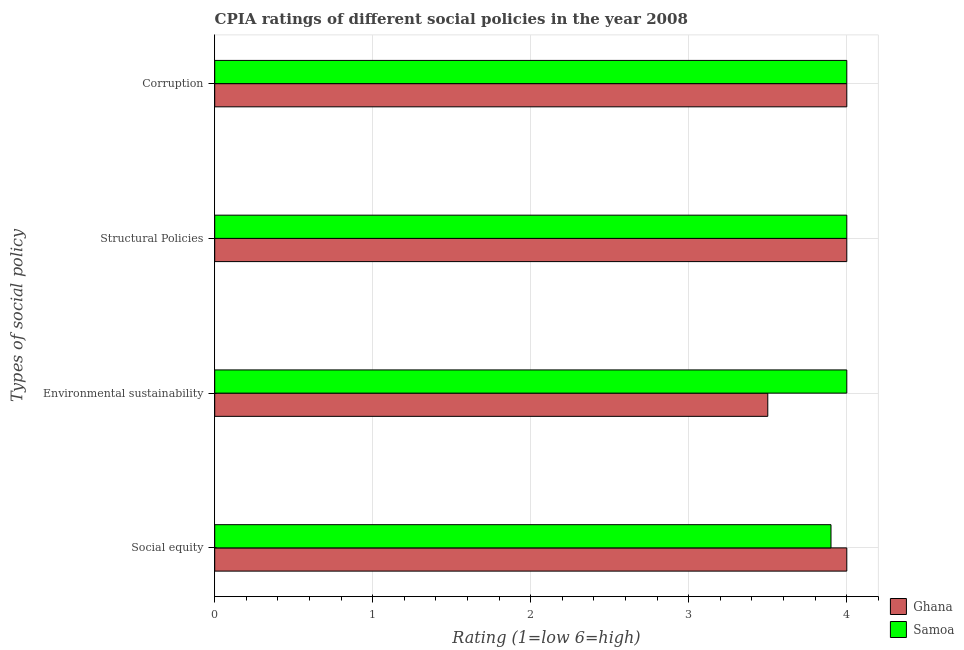How many groups of bars are there?
Provide a succinct answer. 4. Are the number of bars per tick equal to the number of legend labels?
Make the answer very short. Yes. Are the number of bars on each tick of the Y-axis equal?
Make the answer very short. Yes. What is the label of the 2nd group of bars from the top?
Provide a succinct answer. Structural Policies. What is the cpia rating of social equity in Ghana?
Offer a very short reply. 4. Across all countries, what is the maximum cpia rating of structural policies?
Your response must be concise. 4. Across all countries, what is the minimum cpia rating of structural policies?
Your answer should be very brief. 4. What is the difference between the cpia rating of social equity and cpia rating of environmental sustainability in Ghana?
Offer a terse response. 0.5. Is the difference between the cpia rating of corruption in Ghana and Samoa greater than the difference between the cpia rating of social equity in Ghana and Samoa?
Offer a very short reply. No. What is the difference between the highest and the lowest cpia rating of structural policies?
Offer a terse response. 0. Is the sum of the cpia rating of social equity in Samoa and Ghana greater than the maximum cpia rating of environmental sustainability across all countries?
Give a very brief answer. Yes. What does the 1st bar from the top in Corruption represents?
Your response must be concise. Samoa. Are all the bars in the graph horizontal?
Ensure brevity in your answer.  Yes. How many countries are there in the graph?
Your response must be concise. 2. Where does the legend appear in the graph?
Your answer should be compact. Bottom right. How many legend labels are there?
Offer a terse response. 2. How are the legend labels stacked?
Make the answer very short. Vertical. What is the title of the graph?
Keep it short and to the point. CPIA ratings of different social policies in the year 2008. What is the label or title of the Y-axis?
Make the answer very short. Types of social policy. What is the Rating (1=low 6=high) in Ghana in Social equity?
Make the answer very short. 4. What is the Rating (1=low 6=high) of Samoa in Structural Policies?
Offer a terse response. 4. What is the Rating (1=low 6=high) of Samoa in Corruption?
Offer a very short reply. 4. Across all Types of social policy, what is the minimum Rating (1=low 6=high) of Ghana?
Your answer should be very brief. 3.5. Across all Types of social policy, what is the minimum Rating (1=low 6=high) in Samoa?
Give a very brief answer. 3.9. What is the total Rating (1=low 6=high) of Ghana in the graph?
Ensure brevity in your answer.  15.5. What is the total Rating (1=low 6=high) in Samoa in the graph?
Offer a very short reply. 15.9. What is the difference between the Rating (1=low 6=high) in Samoa in Social equity and that in Corruption?
Give a very brief answer. -0.1. What is the difference between the Rating (1=low 6=high) of Samoa in Environmental sustainability and that in Structural Policies?
Provide a succinct answer. 0. What is the difference between the Rating (1=low 6=high) of Ghana in Environmental sustainability and that in Corruption?
Ensure brevity in your answer.  -0.5. What is the difference between the Rating (1=low 6=high) of Ghana in Social equity and the Rating (1=low 6=high) of Samoa in Environmental sustainability?
Keep it short and to the point. 0. What is the difference between the Rating (1=low 6=high) of Ghana in Social equity and the Rating (1=low 6=high) of Samoa in Structural Policies?
Give a very brief answer. 0. What is the difference between the Rating (1=low 6=high) of Ghana in Social equity and the Rating (1=low 6=high) of Samoa in Corruption?
Provide a succinct answer. 0. What is the difference between the Rating (1=low 6=high) in Ghana in Environmental sustainability and the Rating (1=low 6=high) in Samoa in Corruption?
Keep it short and to the point. -0.5. What is the average Rating (1=low 6=high) of Ghana per Types of social policy?
Your answer should be compact. 3.88. What is the average Rating (1=low 6=high) in Samoa per Types of social policy?
Provide a succinct answer. 3.98. What is the difference between the Rating (1=low 6=high) in Ghana and Rating (1=low 6=high) in Samoa in Social equity?
Give a very brief answer. 0.1. What is the difference between the Rating (1=low 6=high) of Ghana and Rating (1=low 6=high) of Samoa in Corruption?
Your answer should be very brief. 0. What is the ratio of the Rating (1=low 6=high) in Samoa in Social equity to that in Environmental sustainability?
Make the answer very short. 0.97. What is the ratio of the Rating (1=low 6=high) of Samoa in Social equity to that in Corruption?
Provide a succinct answer. 0.97. What is the ratio of the Rating (1=low 6=high) of Samoa in Environmental sustainability to that in Structural Policies?
Give a very brief answer. 1. What is the ratio of the Rating (1=low 6=high) in Ghana in Environmental sustainability to that in Corruption?
Your answer should be compact. 0.88. What is the ratio of the Rating (1=low 6=high) of Samoa in Environmental sustainability to that in Corruption?
Provide a succinct answer. 1. What is the difference between the highest and the second highest Rating (1=low 6=high) in Samoa?
Keep it short and to the point. 0. What is the difference between the highest and the lowest Rating (1=low 6=high) of Ghana?
Offer a terse response. 0.5. 